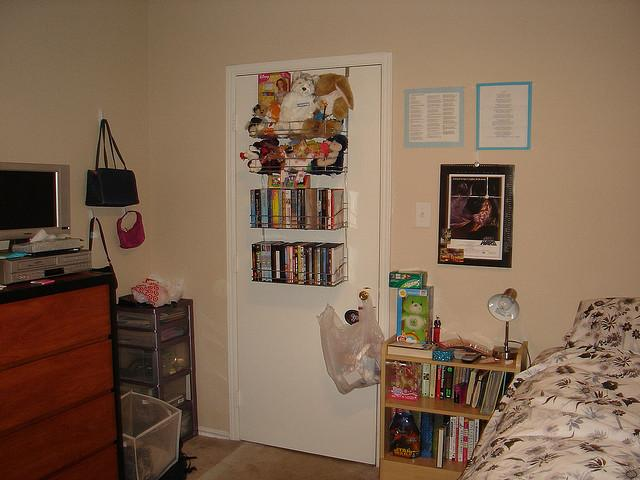What is the plastic bag on the door handle being used to collect? Please explain your reasoning. garbage. They don't have a bin in the room 